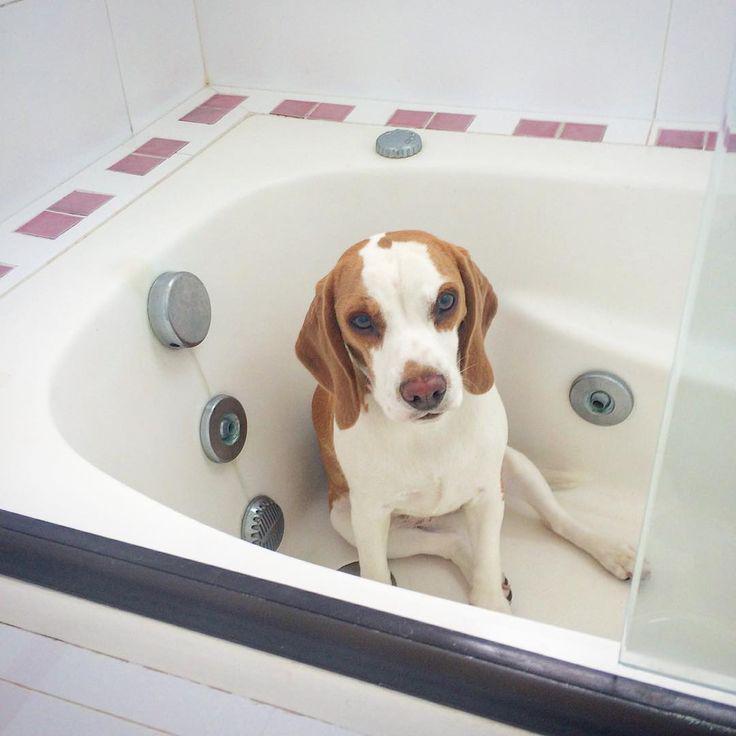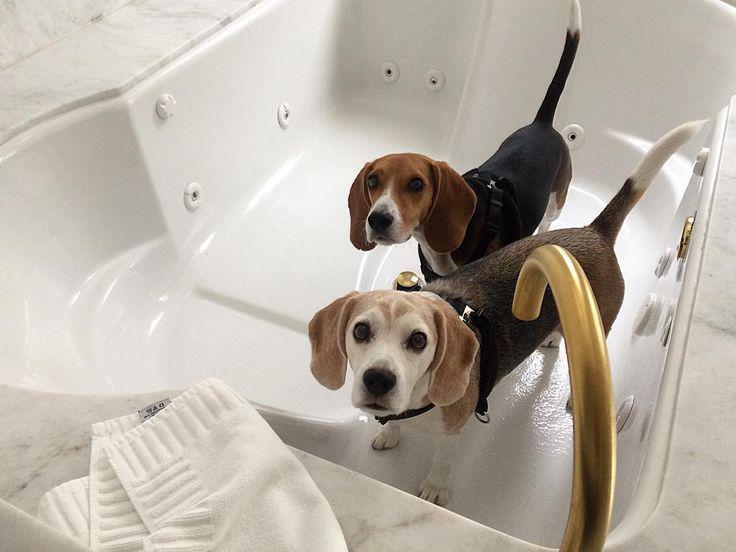The first image is the image on the left, the second image is the image on the right. For the images displayed, is the sentence "In one of the images there is a beagle in the sitting position." factually correct? Answer yes or no. Yes. The first image is the image on the left, the second image is the image on the right. Evaluate the accuracy of this statement regarding the images: "At least one of the puppies is real and is sitting down.". Is it true? Answer yes or no. Yes. 